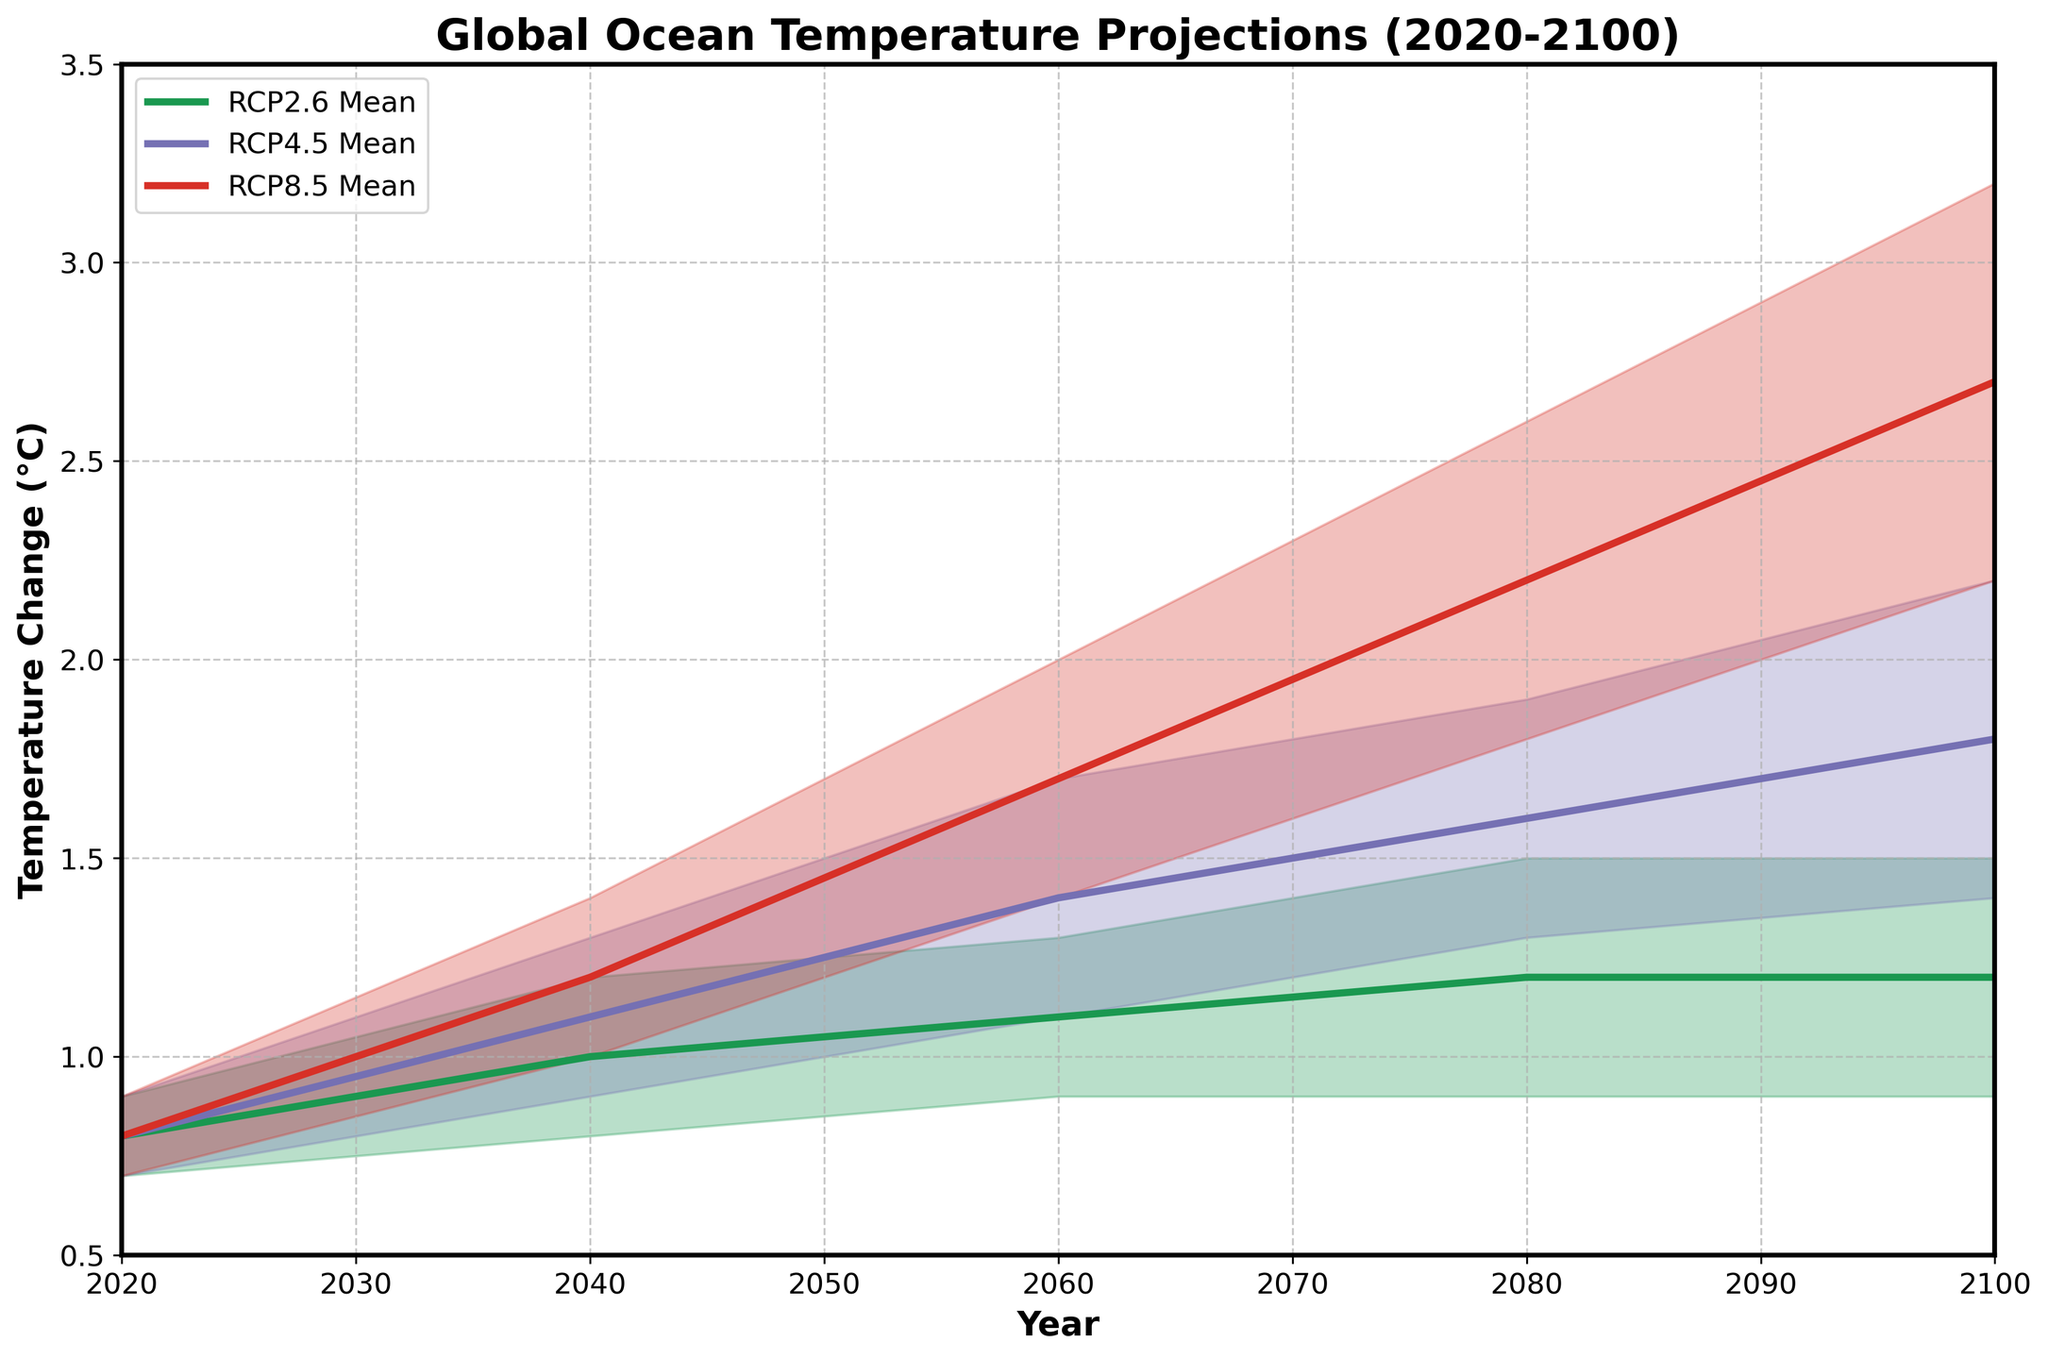What is the title of the chart? The title of the chart is prominently displayed at the top of the figure. By reading it, we can identify the title as "Global Ocean Temperature Projections (2020-2100)."
Answer: Global Ocean Temperature Projections (2020-2100) What is the range of the y-axis? The range of the y-axis is shown on the left side of the chart, which spans from the lowest to the highest labeled values.
Answer: 0.5 to 3.5 Which scenario's mean temperature change is the highest in 2100? By examining the ends of the lines representing mean temperatures for each scenario in 2100, we can see that the RCP8.5 line reaches the highest point.
Answer: RCP8.5 How does the mean change in temperature for RCP4.5 from 2020 to 2040 compare to the change from 2040 to 2060? We first find the mean temperature change for RCP4.5 in 2020, 2040, and 2060, which are 0.8, 1.1, and 1.4 respectively. The change from 2020 to 2040 is 1.1 - 0.8 = 0.3°C, and from 2040 to 2060 is 1.4 - 1.1 = 0.3°C. Thus, both changes are the same.
Answer: They are equal Between which two consecutive decades does RCP2.6 show no increase in mean temperature change? Observing the mean temperature change for RCP2.6, we see that from 2060 to 2100, the values remain at 1.2°C.
Answer: 2060 and 2080 What is the uncertainty range for RCP4.5 mean temperature change in 2080? The uncertainty range can be determined by the difference between the high and low values. The high is 1.9°C and the low is 1.3°C, so the range is 1.9 - 1.3 = 0.6°C.
Answer: 0.6°C Which scenario shows the most significant increase in mean temperature change between 2060 and 2080? We compare the mean temperature changes for all scenarios between 2060 and 2080. RCP8.5 increases from 1.7 to 2.2 (0.5°C), RCP4.5 from 1.4 to 1.6 (0.2°C), and RCP2.6 from 1.1 to 1.2 (0.1°C). Thus, RCP8.5 shows the largest increase.
Answer: RCP8.5 What overall trend is observed in the temperature projections for all scenarios from 2020 to 2100? By looking at the general direction of the lines, we can see that all scenarios show an overall increase in mean temperature over the century.
Answer: Increase Which scenario has the narrowest uncertainty range in 2100? We observe the width of the shaded areas in 2100. RCP2.6 ranges from 0.9 to 1.5 (0.6°C), RCP4.5 from 1.4 to 2.2 (0.8°C), and RCP8.5 from 2.2 to 3.2 (1.0°C). The narrowest uncertainty range belongs to RCP2.6.
Answer: RCP2.6 At which year does RCP8.5’s mean temperature change surpass 2.0°C? Following the RCP8.5 mean line and looking for when it exceeds 2.0°C, we see this occurs around the year 2080.
Answer: 2080 